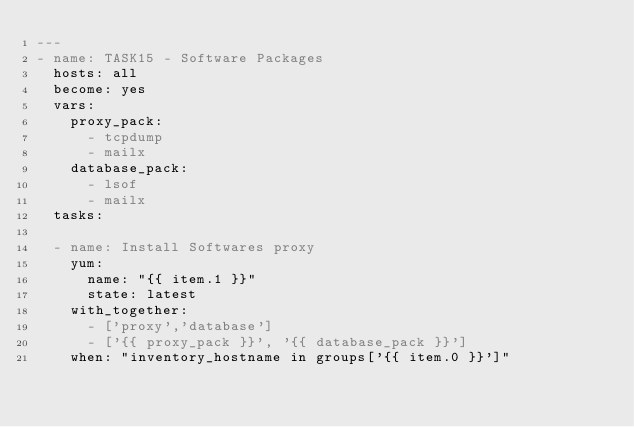Convert code to text. <code><loc_0><loc_0><loc_500><loc_500><_YAML_>---
- name: TASK15 - Software Packages
  hosts: all
  become: yes
  vars:
    proxy_pack:
      - tcpdump
      - mailx
    database_pack:
      - lsof
      - mailx
  tasks:

  - name: Install Softwares proxy
    yum:
      name: "{{ item.1 }}"
      state: latest
    with_together:
      - ['proxy','database']
      - ['{{ proxy_pack }}', '{{ database_pack }}']
    when: "inventory_hostname in groups['{{ item.0 }}']"


</code> 